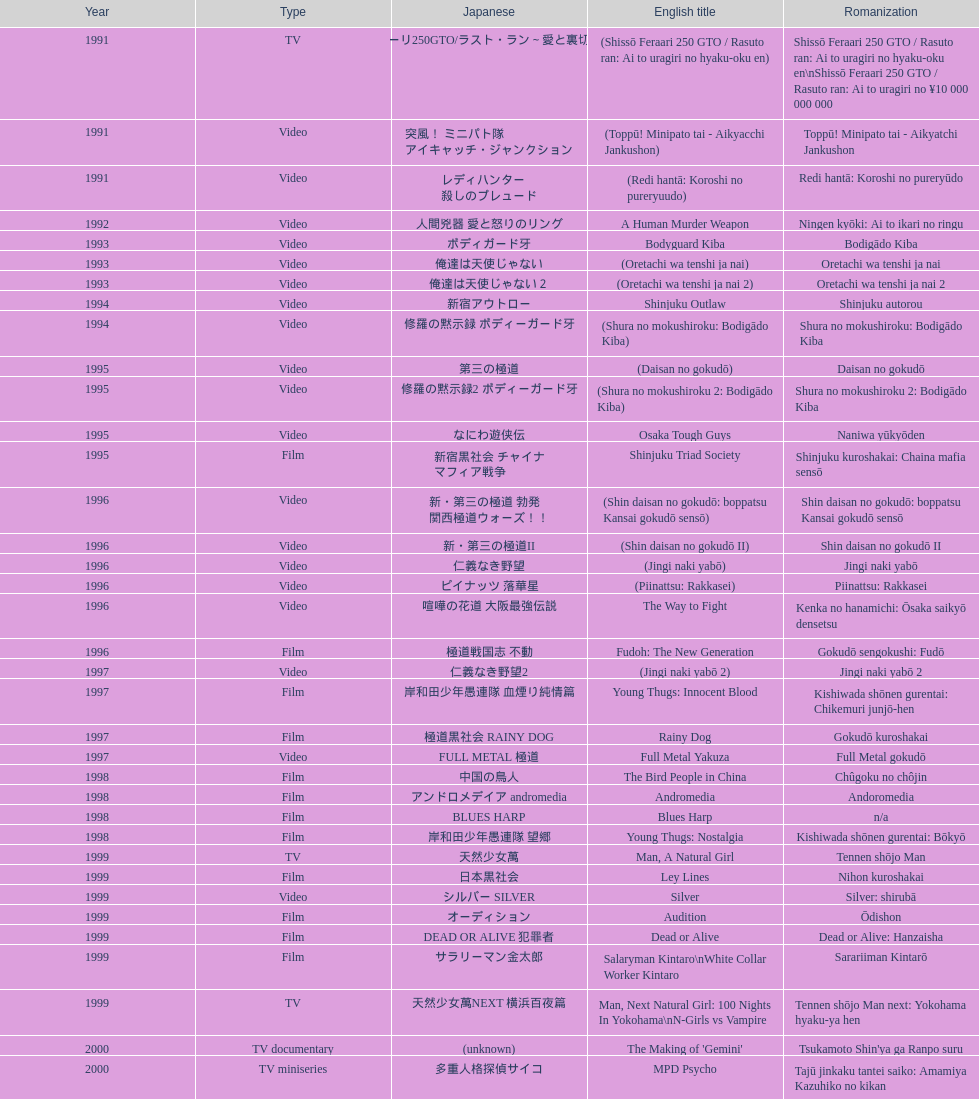Name a film that was released before 1996. Shinjuku Triad Society. 